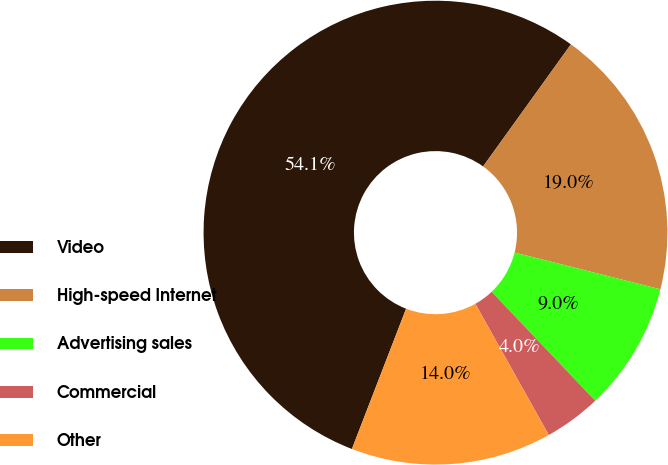Convert chart to OTSL. <chart><loc_0><loc_0><loc_500><loc_500><pie_chart><fcel>Video<fcel>High-speed Internet<fcel>Advertising sales<fcel>Commercial<fcel>Other<nl><fcel>54.05%<fcel>19.0%<fcel>8.98%<fcel>3.97%<fcel>13.99%<nl></chart> 